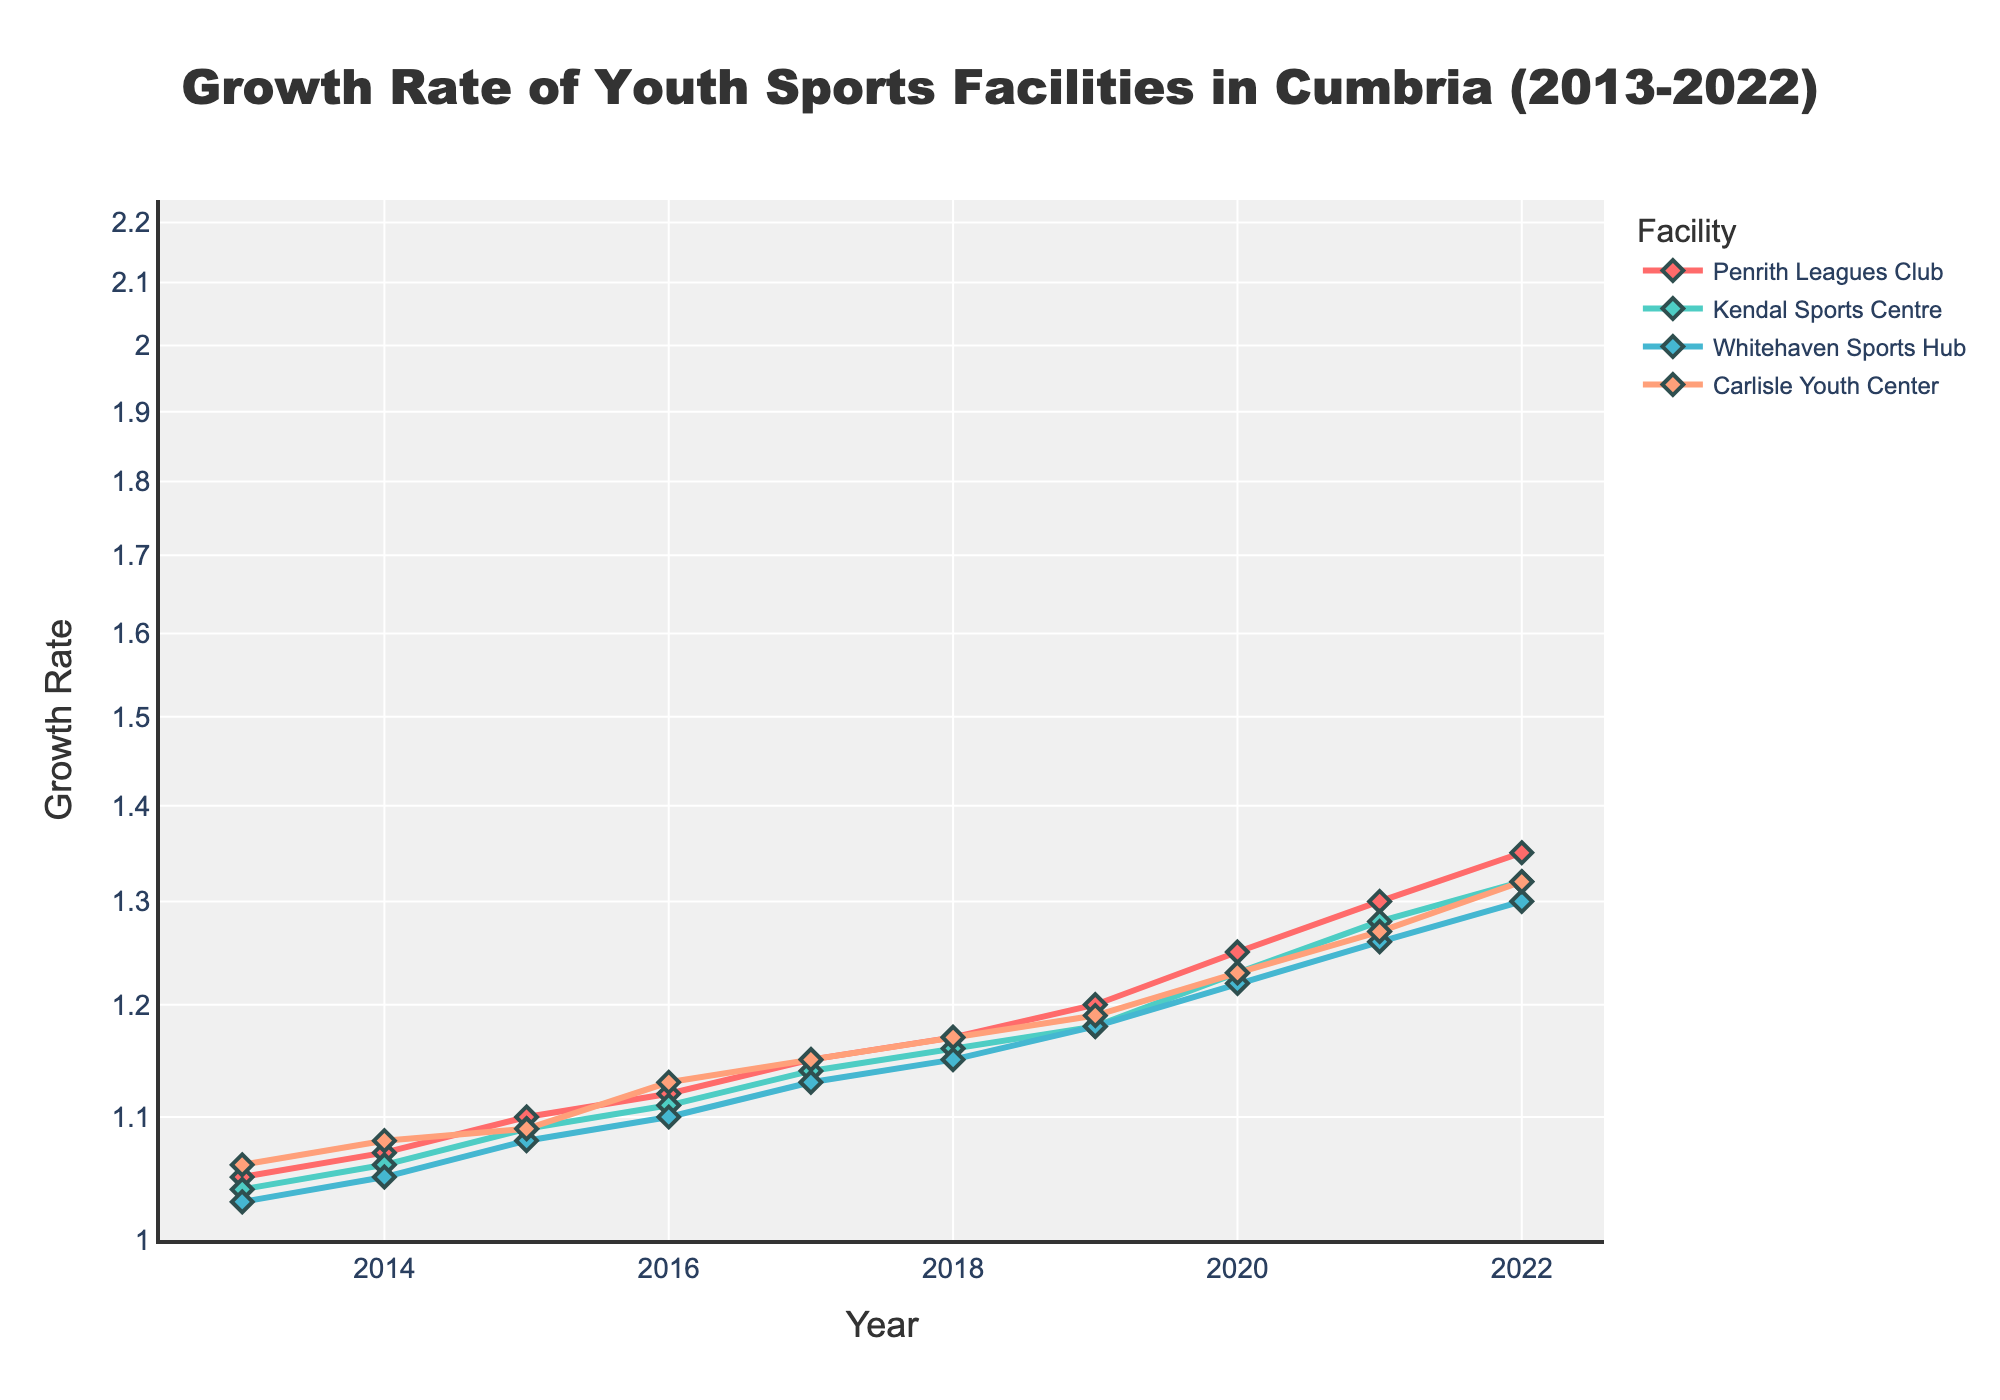What is the title of the plot? The title is located at the top of the figure. It reads: "Growth Rate of Youth Sports Facilities in Cumbria (2013-2022)"
Answer: Growth Rate of Youth Sports Facilities in Cumbria (2013-2022) How many facilities are shown in the plot? By counting the different lines and their markers, we can see four distinct facilities.
Answer: Four Which facility had the highest growth rate in 2022? By following the line for each facility up to 2022, Penrith Leagues Club reaches the highest point.
Answer: Penrith Leagues Club Between which years did Kendal Sports Centre see the largest increase in growth rate? By observing the steepness of the line for Kendal Sports Centre, the largest growth occurs between 2020 and 2021.
Answer: 2020-2021 What is the general trend of the growth rates for all facilities? Observing the overall direction of the lines, all facilities show an upward trend, indicating increased growth rates over time.
Answer: Upward trend Considering the log scale, what can be inferred about the growth rate changes? The log scale compresses the visual differences, but all facilities exhibit exponential growth as they appear as straight lines sloping upward.
Answer: Exponential growth Which facility had the smallest growth rate increase between 2013 and 2022? Plotting the differences, Whitehaven Sports Hub starts at 1.03 and ends at 1.30 which is a smaller increase compared to others.
Answer: Whitehaven Sports Hub How does the growth rate of Carlisle Youth Center in 2021 compare to that of Whitehaven Sports Hub in 2021? By comparing the points at 2021 on the y-axis for each facility, Carlisle Youth Center (1.27) is slightly lower than Whitehaven Sports Hub (1.26).
Answer: Carlisle Youth Center is slightly lower If the trend continues, what would be the approximate growth rate for Penrith Leagues Club in 2023? Extending the linear pattern of the log-scale line beyond the available data, the growth rate would likely continue to increase similarly, estimating around 1.40 to 1.45.
Answer: Approximately 1.40 to 1.45 Which year showed minimal difference in growth rates among all facilities? Observing the y-values where the lines are closest, in 2014 and 2015, the difference in growth rates among all facilities appears minimal.
Answer: 2014-2015 